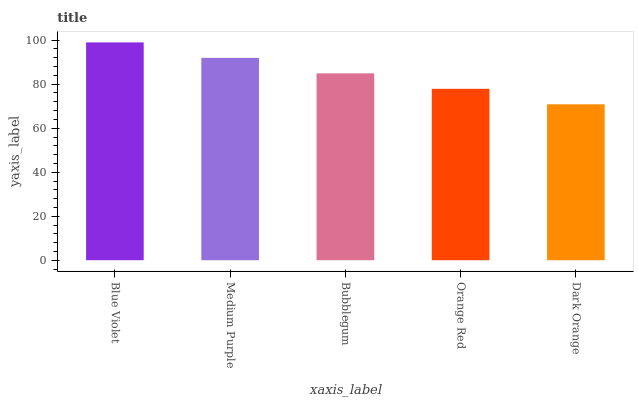Is Dark Orange the minimum?
Answer yes or no. Yes. Is Blue Violet the maximum?
Answer yes or no. Yes. Is Medium Purple the minimum?
Answer yes or no. No. Is Medium Purple the maximum?
Answer yes or no. No. Is Blue Violet greater than Medium Purple?
Answer yes or no. Yes. Is Medium Purple less than Blue Violet?
Answer yes or no. Yes. Is Medium Purple greater than Blue Violet?
Answer yes or no. No. Is Blue Violet less than Medium Purple?
Answer yes or no. No. Is Bubblegum the high median?
Answer yes or no. Yes. Is Bubblegum the low median?
Answer yes or no. Yes. Is Medium Purple the high median?
Answer yes or no. No. Is Dark Orange the low median?
Answer yes or no. No. 